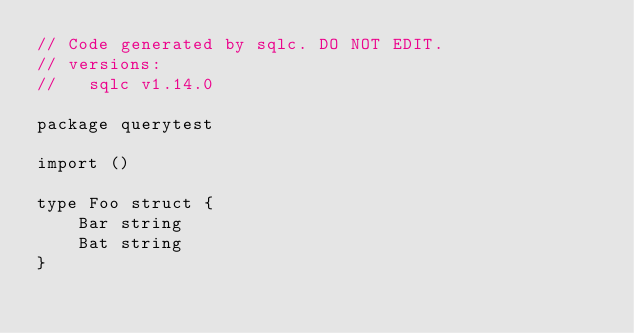Convert code to text. <code><loc_0><loc_0><loc_500><loc_500><_Go_>// Code generated by sqlc. DO NOT EDIT.
// versions:
//   sqlc v1.14.0

package querytest

import ()

type Foo struct {
	Bar string
	Bat string
}
</code> 